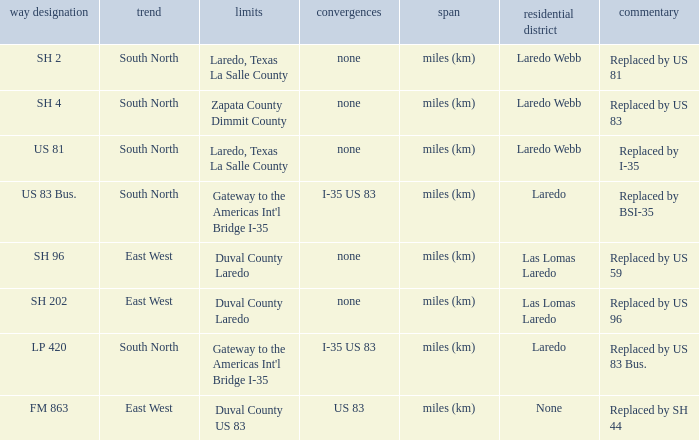Which routes have  "replaced by US 81" listed in their remarks section? SH 2. 